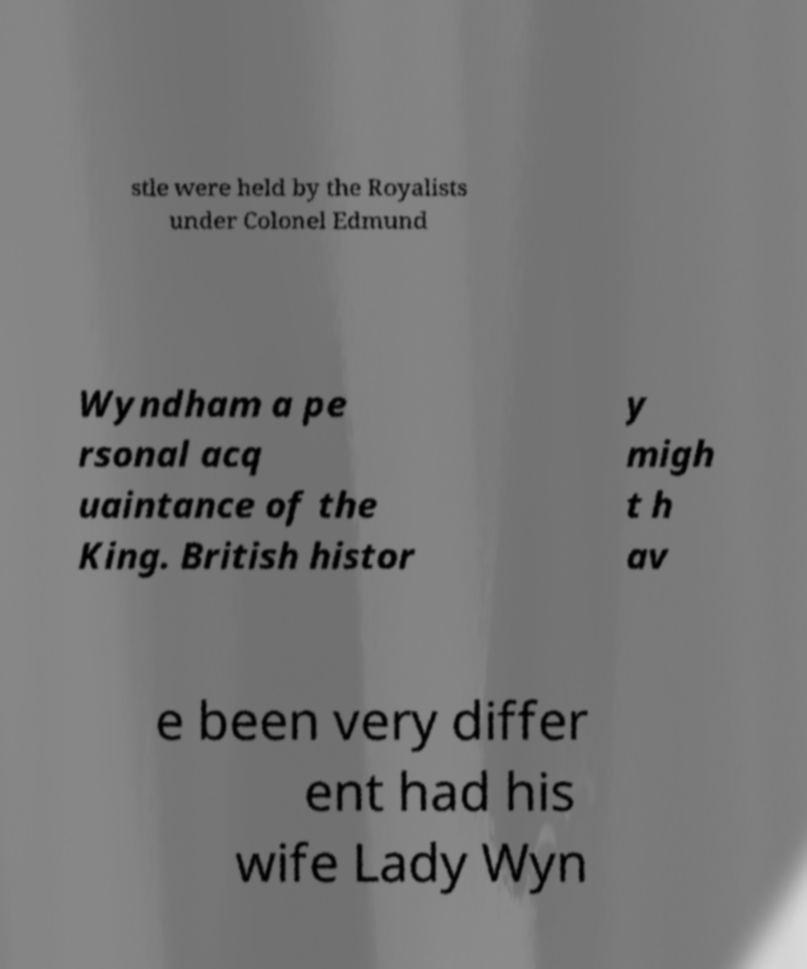Can you read and provide the text displayed in the image?This photo seems to have some interesting text. Can you extract and type it out for me? stle were held by the Royalists under Colonel Edmund Wyndham a pe rsonal acq uaintance of the King. British histor y migh t h av e been very differ ent had his wife Lady Wyn 